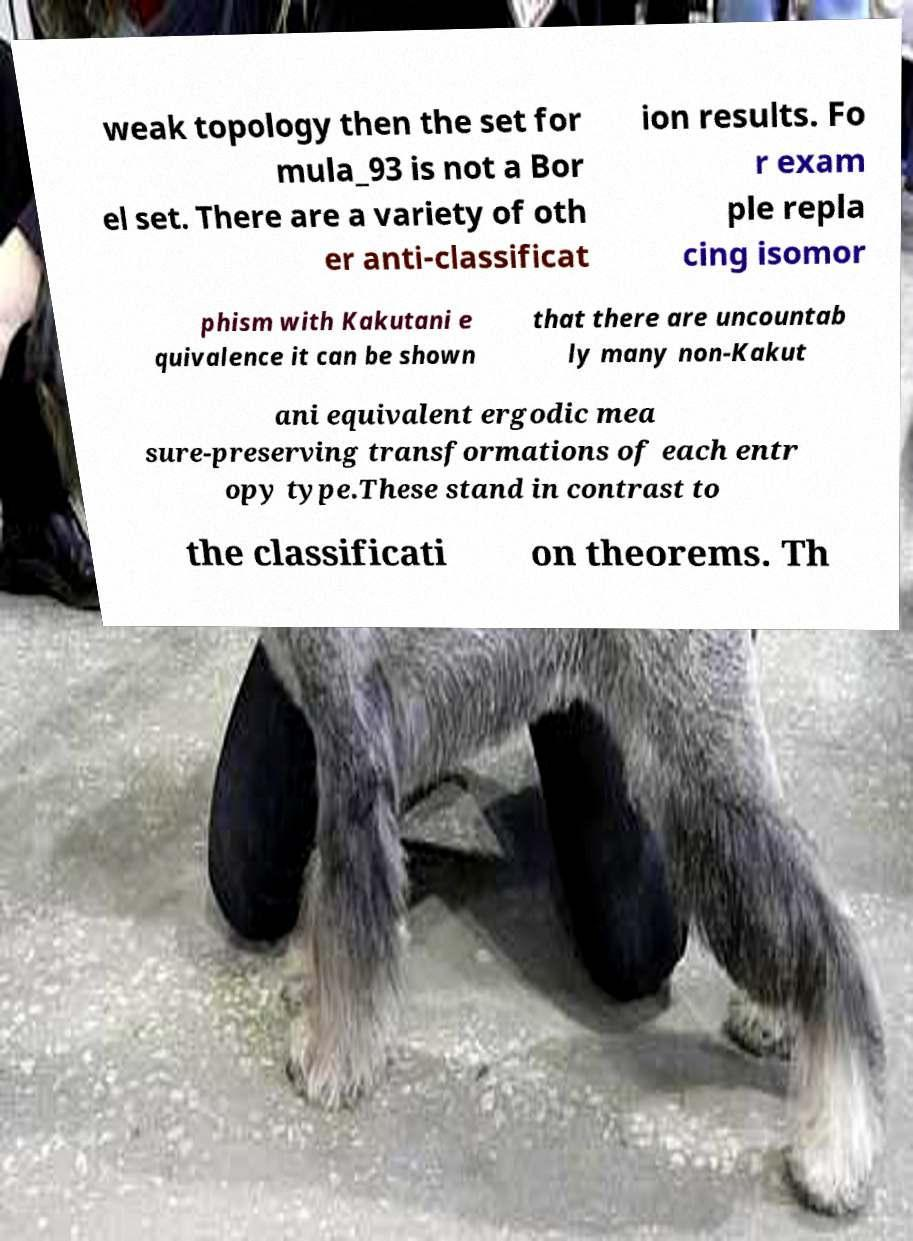Can you read and provide the text displayed in the image?This photo seems to have some interesting text. Can you extract and type it out for me? weak topology then the set for mula_93 is not a Bor el set. There are a variety of oth er anti-classificat ion results. Fo r exam ple repla cing isomor phism with Kakutani e quivalence it can be shown that there are uncountab ly many non-Kakut ani equivalent ergodic mea sure-preserving transformations of each entr opy type.These stand in contrast to the classificati on theorems. Th 